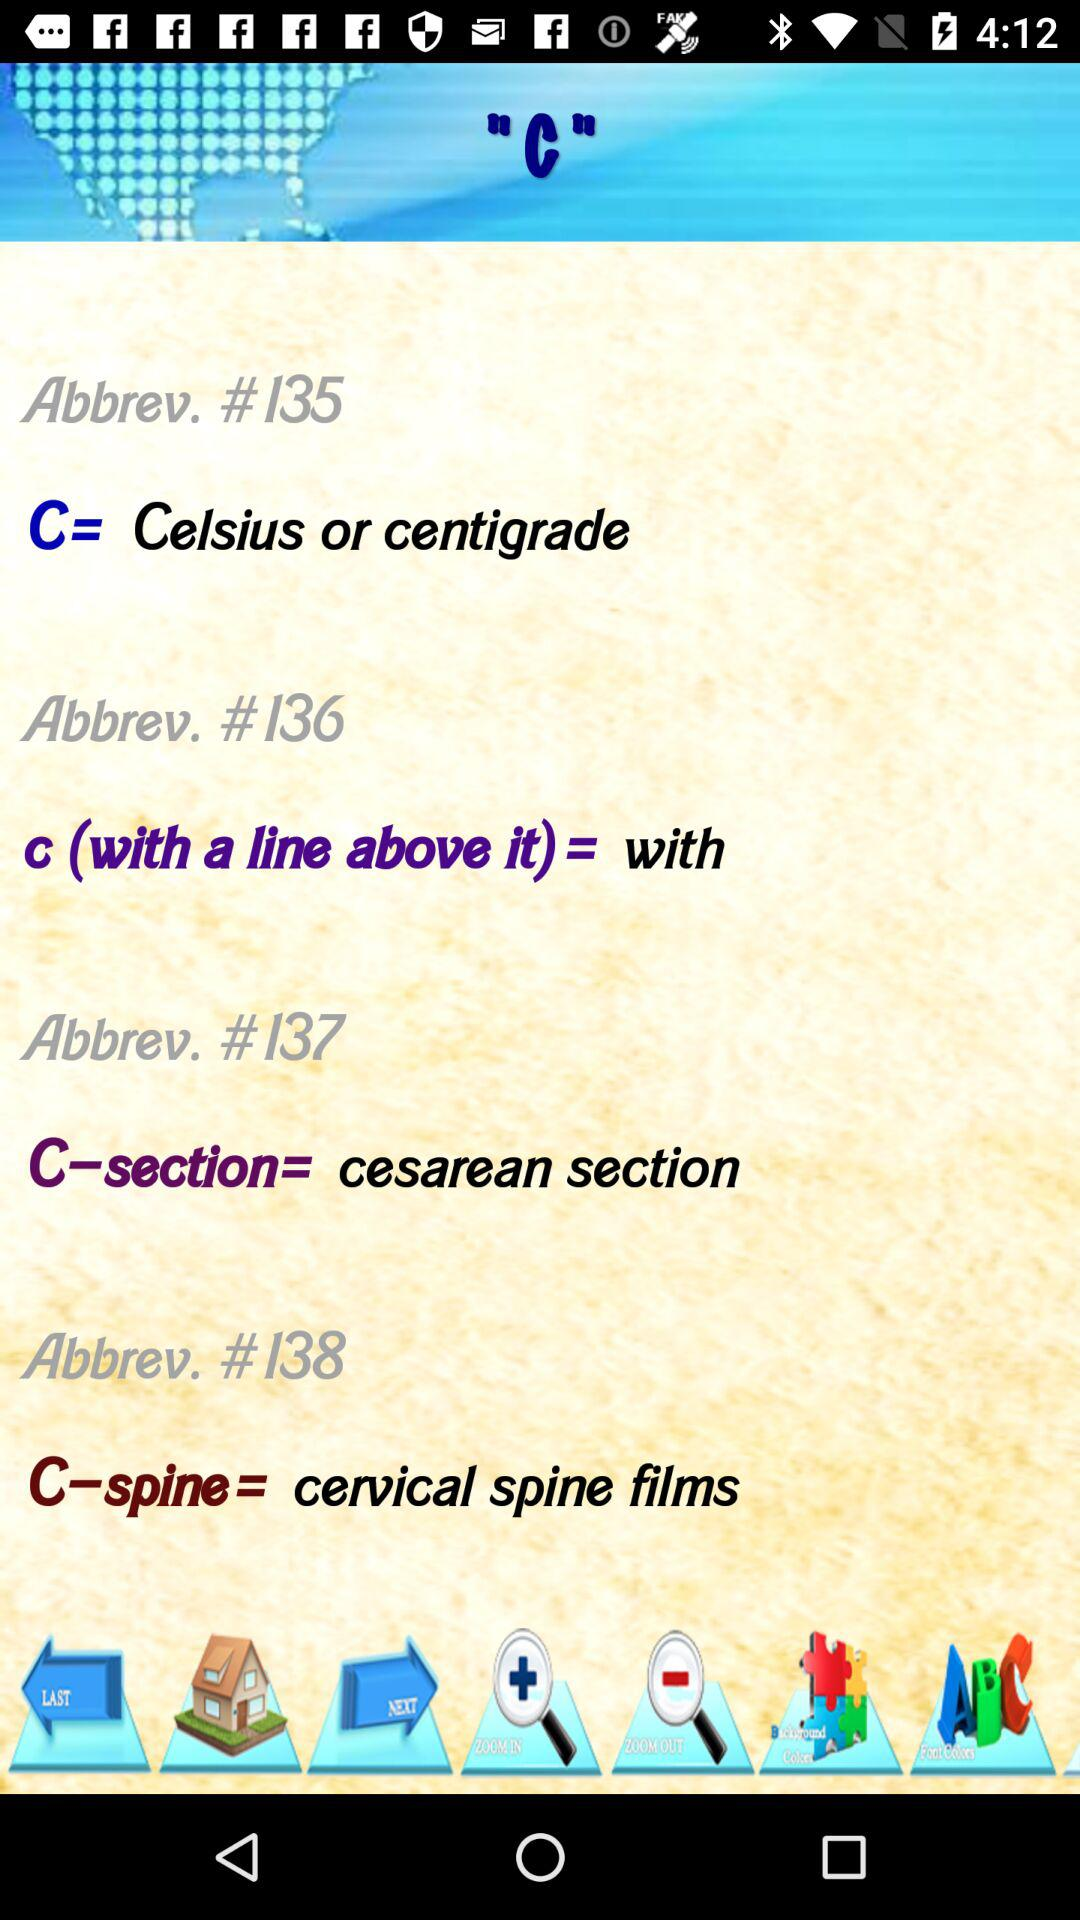What is the abbrev. number of the cesarean section? The abbrev. number of the cesarean section is 137. 